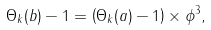<formula> <loc_0><loc_0><loc_500><loc_500>\Theta _ { k } ( b ) - 1 = \left ( \Theta _ { k } ( a ) - 1 \right ) \times \phi ^ { 3 } ,</formula> 